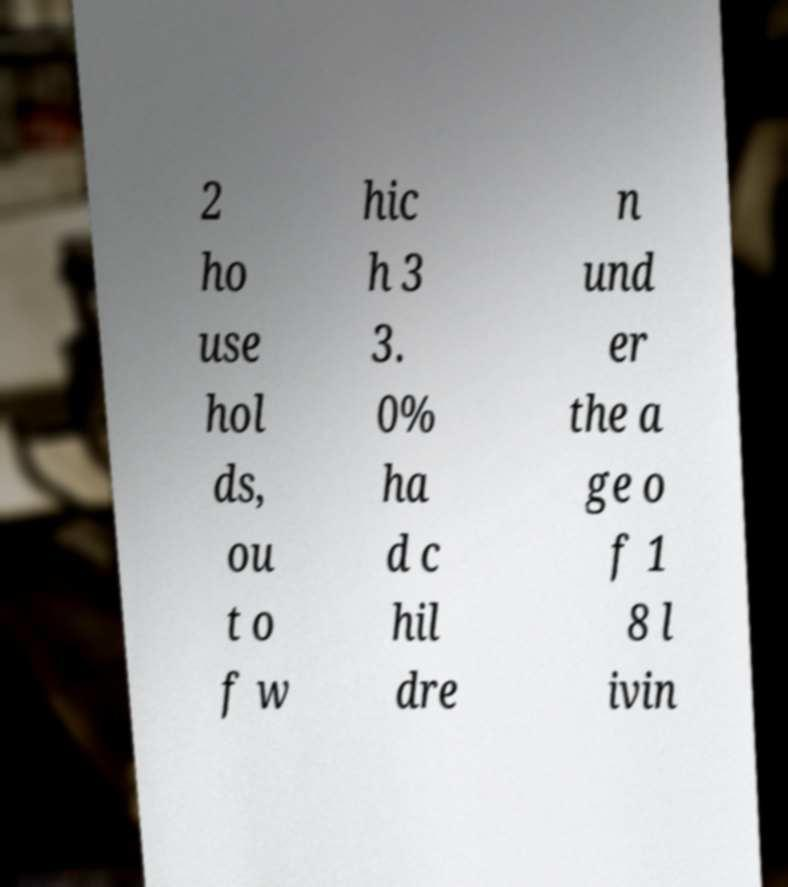Could you assist in decoding the text presented in this image and type it out clearly? 2 ho use hol ds, ou t o f w hic h 3 3. 0% ha d c hil dre n und er the a ge o f 1 8 l ivin 